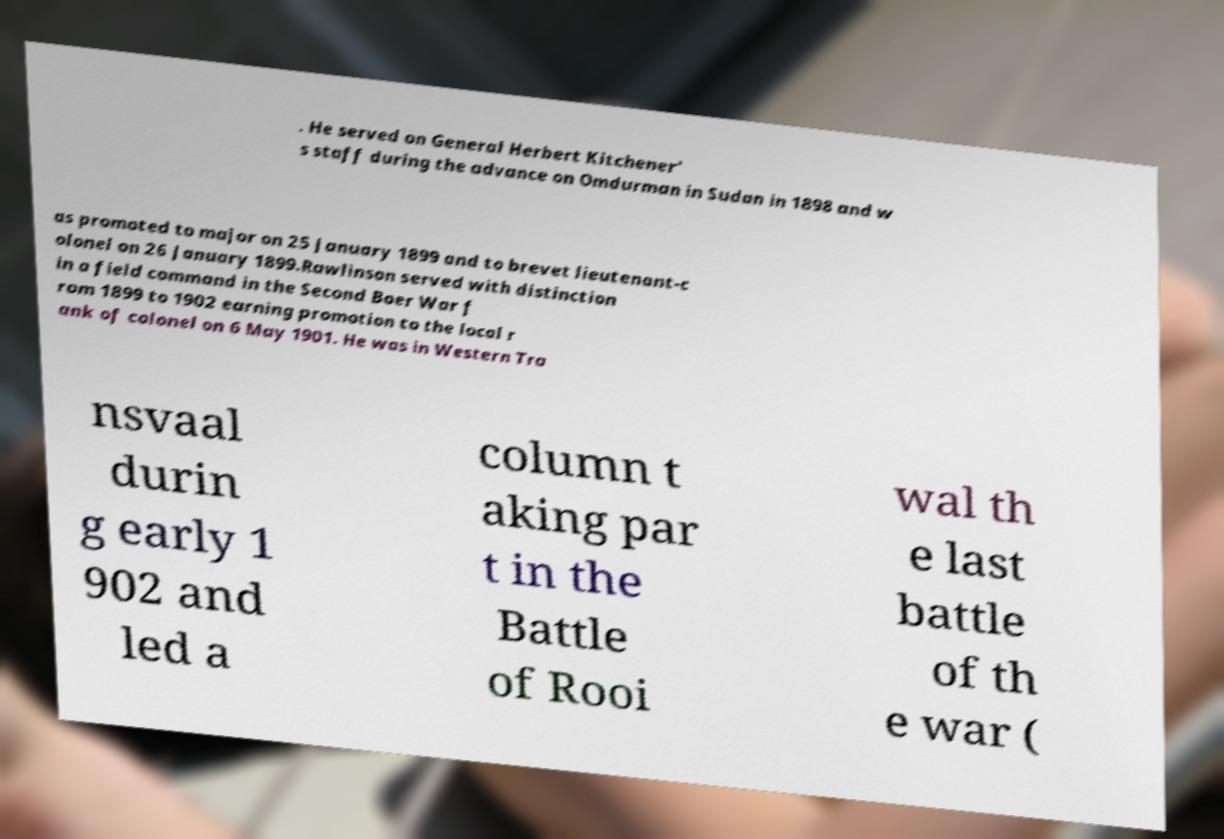There's text embedded in this image that I need extracted. Can you transcribe it verbatim? . He served on General Herbert Kitchener' s staff during the advance on Omdurman in Sudan in 1898 and w as promoted to major on 25 January 1899 and to brevet lieutenant-c olonel on 26 January 1899.Rawlinson served with distinction in a field command in the Second Boer War f rom 1899 to 1902 earning promotion to the local r ank of colonel on 6 May 1901. He was in Western Tra nsvaal durin g early 1 902 and led a column t aking par t in the Battle of Rooi wal th e last battle of th e war ( 